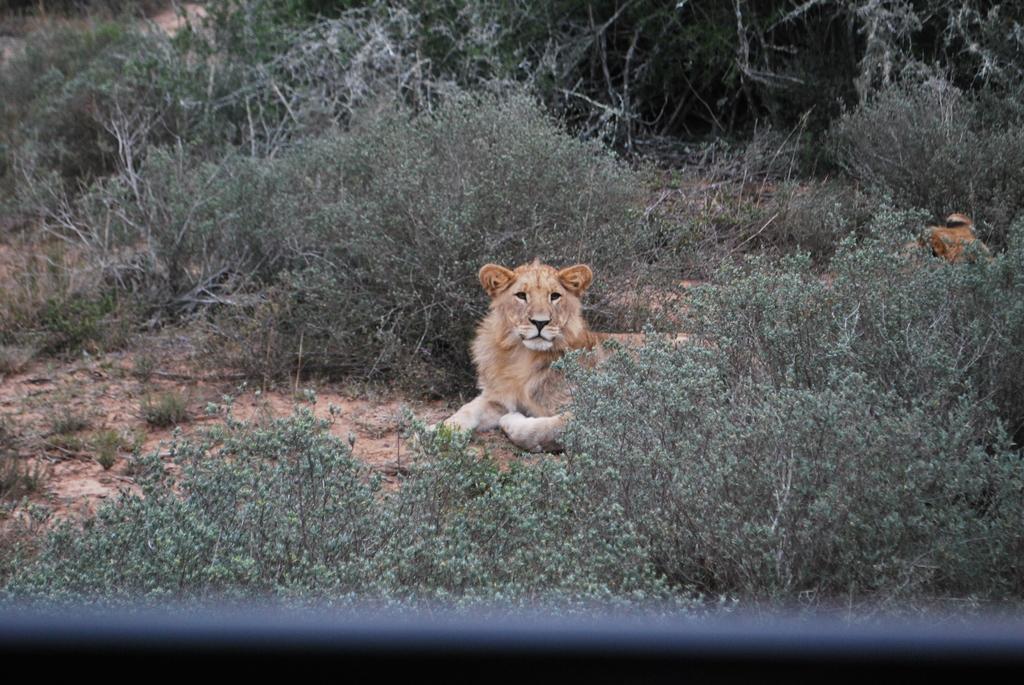Could you give a brief overview of what you see in this image? In this image we can see a lion on the ground and plants. 